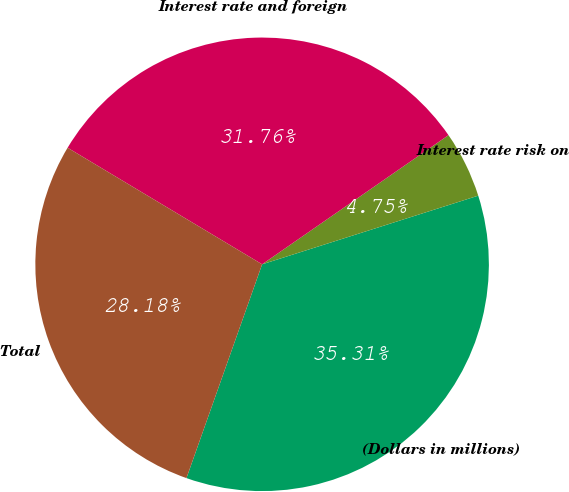<chart> <loc_0><loc_0><loc_500><loc_500><pie_chart><fcel>(Dollars in millions)<fcel>Interest rate risk on<fcel>Interest rate and foreign<fcel>Total<nl><fcel>35.31%<fcel>4.75%<fcel>31.76%<fcel>28.18%<nl></chart> 